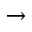<formula> <loc_0><loc_0><loc_500><loc_500>\to</formula> 